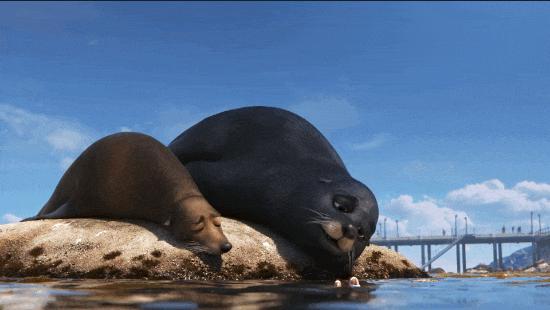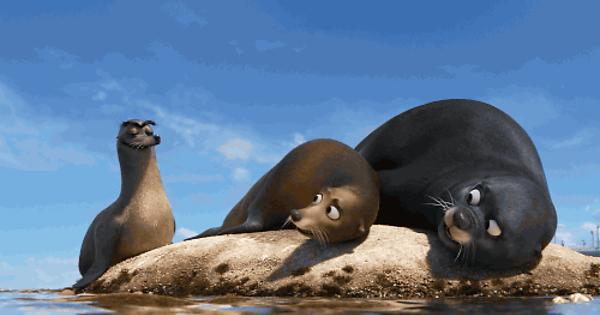The first image is the image on the left, the second image is the image on the right. For the images displayed, is the sentence "An image includes a large seal with wide-open mouth and a smaller seal with a closed mouth." factually correct? Answer yes or no. No. 